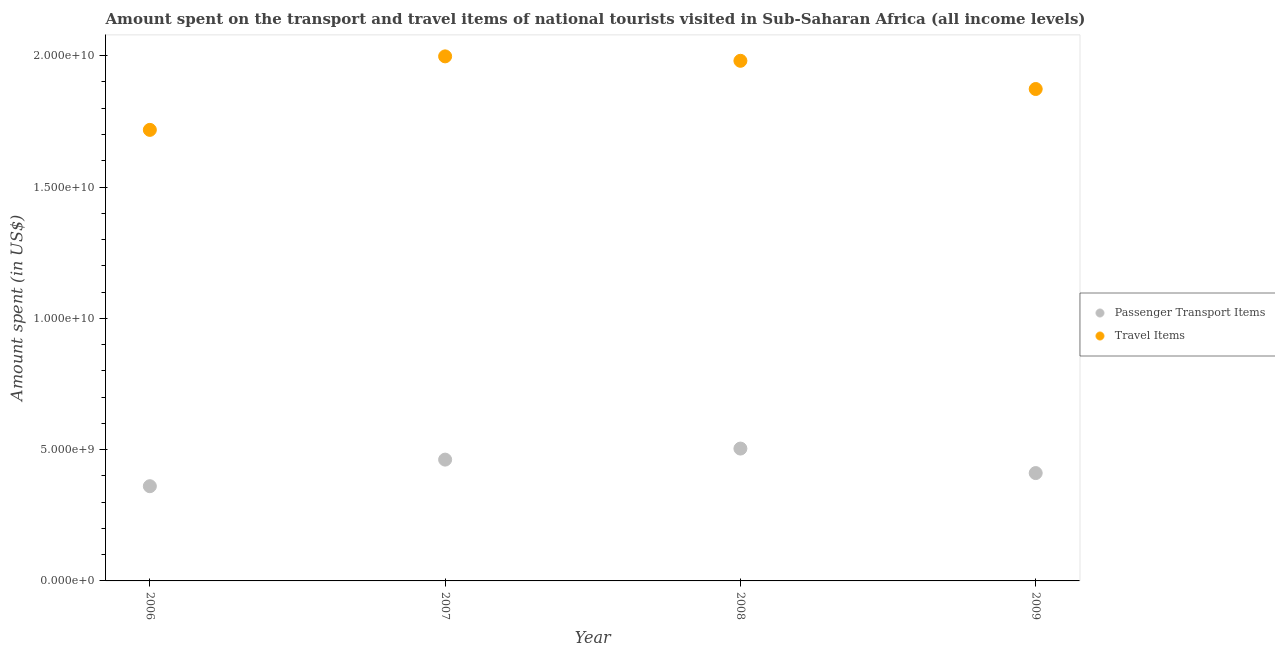Is the number of dotlines equal to the number of legend labels?
Provide a succinct answer. Yes. What is the amount spent on passenger transport items in 2009?
Keep it short and to the point. 4.11e+09. Across all years, what is the maximum amount spent on passenger transport items?
Provide a succinct answer. 5.04e+09. Across all years, what is the minimum amount spent on passenger transport items?
Keep it short and to the point. 3.61e+09. In which year was the amount spent in travel items minimum?
Your response must be concise. 2006. What is the total amount spent in travel items in the graph?
Give a very brief answer. 7.57e+1. What is the difference between the amount spent in travel items in 2007 and that in 2009?
Ensure brevity in your answer.  1.24e+09. What is the difference between the amount spent on passenger transport items in 2006 and the amount spent in travel items in 2009?
Your answer should be very brief. -1.51e+1. What is the average amount spent on passenger transport items per year?
Your answer should be very brief. 4.34e+09. In the year 2009, what is the difference between the amount spent in travel items and amount spent on passenger transport items?
Give a very brief answer. 1.46e+1. In how many years, is the amount spent in travel items greater than 19000000000 US$?
Give a very brief answer. 2. What is the ratio of the amount spent in travel items in 2006 to that in 2008?
Ensure brevity in your answer.  0.87. Is the amount spent on passenger transport items in 2006 less than that in 2007?
Offer a very short reply. Yes. Is the difference between the amount spent in travel items in 2007 and 2008 greater than the difference between the amount spent on passenger transport items in 2007 and 2008?
Ensure brevity in your answer.  Yes. What is the difference between the highest and the second highest amount spent in travel items?
Keep it short and to the point. 1.69e+08. What is the difference between the highest and the lowest amount spent in travel items?
Provide a succinct answer. 2.80e+09. Is the sum of the amount spent in travel items in 2006 and 2009 greater than the maximum amount spent on passenger transport items across all years?
Give a very brief answer. Yes. Is the amount spent on passenger transport items strictly greater than the amount spent in travel items over the years?
Make the answer very short. No. How many dotlines are there?
Your answer should be very brief. 2. Are the values on the major ticks of Y-axis written in scientific E-notation?
Provide a succinct answer. Yes. Does the graph contain grids?
Provide a succinct answer. No. Where does the legend appear in the graph?
Keep it short and to the point. Center right. How many legend labels are there?
Provide a succinct answer. 2. How are the legend labels stacked?
Provide a succinct answer. Vertical. What is the title of the graph?
Keep it short and to the point. Amount spent on the transport and travel items of national tourists visited in Sub-Saharan Africa (all income levels). Does "Malaria" appear as one of the legend labels in the graph?
Keep it short and to the point. No. What is the label or title of the Y-axis?
Offer a terse response. Amount spent (in US$). What is the Amount spent (in US$) of Passenger Transport Items in 2006?
Provide a succinct answer. 3.61e+09. What is the Amount spent (in US$) in Travel Items in 2006?
Make the answer very short. 1.72e+1. What is the Amount spent (in US$) in Passenger Transport Items in 2007?
Ensure brevity in your answer.  4.62e+09. What is the Amount spent (in US$) of Travel Items in 2007?
Provide a succinct answer. 2.00e+1. What is the Amount spent (in US$) in Passenger Transport Items in 2008?
Offer a very short reply. 5.04e+09. What is the Amount spent (in US$) of Travel Items in 2008?
Keep it short and to the point. 1.98e+1. What is the Amount spent (in US$) in Passenger Transport Items in 2009?
Keep it short and to the point. 4.11e+09. What is the Amount spent (in US$) in Travel Items in 2009?
Provide a succinct answer. 1.87e+1. Across all years, what is the maximum Amount spent (in US$) of Passenger Transport Items?
Make the answer very short. 5.04e+09. Across all years, what is the maximum Amount spent (in US$) of Travel Items?
Make the answer very short. 2.00e+1. Across all years, what is the minimum Amount spent (in US$) of Passenger Transport Items?
Your response must be concise. 3.61e+09. Across all years, what is the minimum Amount spent (in US$) in Travel Items?
Make the answer very short. 1.72e+1. What is the total Amount spent (in US$) of Passenger Transport Items in the graph?
Your answer should be compact. 1.74e+1. What is the total Amount spent (in US$) in Travel Items in the graph?
Your answer should be compact. 7.57e+1. What is the difference between the Amount spent (in US$) of Passenger Transport Items in 2006 and that in 2007?
Ensure brevity in your answer.  -1.01e+09. What is the difference between the Amount spent (in US$) of Travel Items in 2006 and that in 2007?
Offer a very short reply. -2.80e+09. What is the difference between the Amount spent (in US$) in Passenger Transport Items in 2006 and that in 2008?
Provide a short and direct response. -1.43e+09. What is the difference between the Amount spent (in US$) in Travel Items in 2006 and that in 2008?
Give a very brief answer. -2.63e+09. What is the difference between the Amount spent (in US$) of Passenger Transport Items in 2006 and that in 2009?
Make the answer very short. -5.00e+08. What is the difference between the Amount spent (in US$) in Travel Items in 2006 and that in 2009?
Offer a very short reply. -1.56e+09. What is the difference between the Amount spent (in US$) in Passenger Transport Items in 2007 and that in 2008?
Your answer should be very brief. -4.21e+08. What is the difference between the Amount spent (in US$) of Travel Items in 2007 and that in 2008?
Ensure brevity in your answer.  1.69e+08. What is the difference between the Amount spent (in US$) in Passenger Transport Items in 2007 and that in 2009?
Your answer should be very brief. 5.12e+08. What is the difference between the Amount spent (in US$) of Travel Items in 2007 and that in 2009?
Provide a succinct answer. 1.24e+09. What is the difference between the Amount spent (in US$) of Passenger Transport Items in 2008 and that in 2009?
Make the answer very short. 9.33e+08. What is the difference between the Amount spent (in US$) of Travel Items in 2008 and that in 2009?
Offer a terse response. 1.07e+09. What is the difference between the Amount spent (in US$) of Passenger Transport Items in 2006 and the Amount spent (in US$) of Travel Items in 2007?
Offer a terse response. -1.64e+1. What is the difference between the Amount spent (in US$) of Passenger Transport Items in 2006 and the Amount spent (in US$) of Travel Items in 2008?
Ensure brevity in your answer.  -1.62e+1. What is the difference between the Amount spent (in US$) in Passenger Transport Items in 2006 and the Amount spent (in US$) in Travel Items in 2009?
Offer a terse response. -1.51e+1. What is the difference between the Amount spent (in US$) of Passenger Transport Items in 2007 and the Amount spent (in US$) of Travel Items in 2008?
Offer a very short reply. -1.52e+1. What is the difference between the Amount spent (in US$) of Passenger Transport Items in 2007 and the Amount spent (in US$) of Travel Items in 2009?
Your answer should be compact. -1.41e+1. What is the difference between the Amount spent (in US$) of Passenger Transport Items in 2008 and the Amount spent (in US$) of Travel Items in 2009?
Your answer should be compact. -1.37e+1. What is the average Amount spent (in US$) in Passenger Transport Items per year?
Offer a terse response. 4.34e+09. What is the average Amount spent (in US$) in Travel Items per year?
Make the answer very short. 1.89e+1. In the year 2006, what is the difference between the Amount spent (in US$) of Passenger Transport Items and Amount spent (in US$) of Travel Items?
Offer a very short reply. -1.36e+1. In the year 2007, what is the difference between the Amount spent (in US$) of Passenger Transport Items and Amount spent (in US$) of Travel Items?
Your answer should be compact. -1.54e+1. In the year 2008, what is the difference between the Amount spent (in US$) in Passenger Transport Items and Amount spent (in US$) in Travel Items?
Your response must be concise. -1.48e+1. In the year 2009, what is the difference between the Amount spent (in US$) of Passenger Transport Items and Amount spent (in US$) of Travel Items?
Provide a succinct answer. -1.46e+1. What is the ratio of the Amount spent (in US$) in Passenger Transport Items in 2006 to that in 2007?
Your answer should be very brief. 0.78. What is the ratio of the Amount spent (in US$) of Travel Items in 2006 to that in 2007?
Make the answer very short. 0.86. What is the ratio of the Amount spent (in US$) of Passenger Transport Items in 2006 to that in 2008?
Keep it short and to the point. 0.72. What is the ratio of the Amount spent (in US$) of Travel Items in 2006 to that in 2008?
Provide a succinct answer. 0.87. What is the ratio of the Amount spent (in US$) in Passenger Transport Items in 2006 to that in 2009?
Your answer should be compact. 0.88. What is the ratio of the Amount spent (in US$) in Travel Items in 2006 to that in 2009?
Make the answer very short. 0.92. What is the ratio of the Amount spent (in US$) in Passenger Transport Items in 2007 to that in 2008?
Your answer should be very brief. 0.92. What is the ratio of the Amount spent (in US$) in Travel Items in 2007 to that in 2008?
Provide a succinct answer. 1.01. What is the ratio of the Amount spent (in US$) in Passenger Transport Items in 2007 to that in 2009?
Ensure brevity in your answer.  1.12. What is the ratio of the Amount spent (in US$) of Travel Items in 2007 to that in 2009?
Your response must be concise. 1.07. What is the ratio of the Amount spent (in US$) in Passenger Transport Items in 2008 to that in 2009?
Offer a very short reply. 1.23. What is the ratio of the Amount spent (in US$) of Travel Items in 2008 to that in 2009?
Provide a succinct answer. 1.06. What is the difference between the highest and the second highest Amount spent (in US$) of Passenger Transport Items?
Ensure brevity in your answer.  4.21e+08. What is the difference between the highest and the second highest Amount spent (in US$) in Travel Items?
Your answer should be compact. 1.69e+08. What is the difference between the highest and the lowest Amount spent (in US$) of Passenger Transport Items?
Offer a very short reply. 1.43e+09. What is the difference between the highest and the lowest Amount spent (in US$) of Travel Items?
Your answer should be very brief. 2.80e+09. 